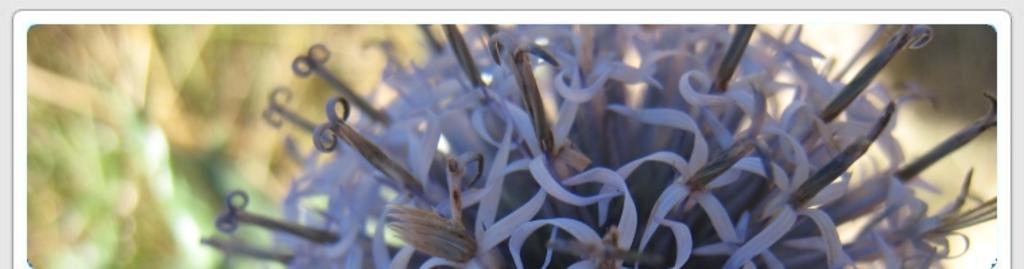Please provide a concise description of this image. In this picture, there is a flower which is in purple in color. 